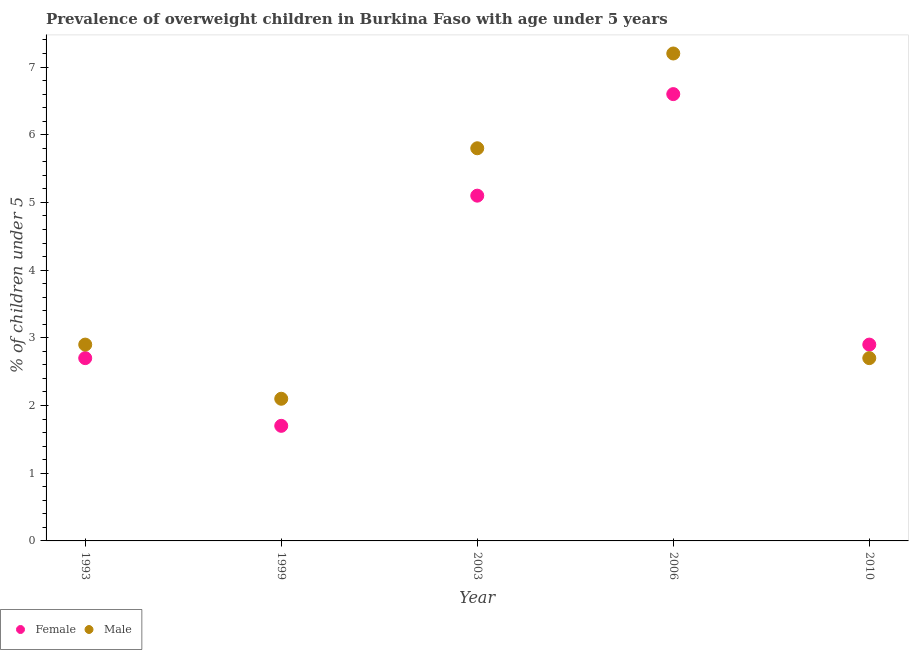What is the percentage of obese male children in 2003?
Ensure brevity in your answer.  5.8. Across all years, what is the maximum percentage of obese male children?
Provide a short and direct response. 7.2. Across all years, what is the minimum percentage of obese male children?
Your response must be concise. 2.1. In which year was the percentage of obese female children maximum?
Provide a short and direct response. 2006. In which year was the percentage of obese female children minimum?
Give a very brief answer. 1999. What is the total percentage of obese female children in the graph?
Provide a short and direct response. 19. What is the difference between the percentage of obese female children in 1999 and that in 2010?
Keep it short and to the point. -1.2. What is the difference between the percentage of obese male children in 2003 and the percentage of obese female children in 2010?
Provide a succinct answer. 2.9. What is the average percentage of obese male children per year?
Offer a very short reply. 4.14. In the year 2010, what is the difference between the percentage of obese male children and percentage of obese female children?
Provide a short and direct response. -0.2. In how many years, is the percentage of obese male children greater than 1 %?
Your response must be concise. 5. What is the ratio of the percentage of obese female children in 1999 to that in 2003?
Make the answer very short. 0.33. Is the difference between the percentage of obese female children in 2006 and 2010 greater than the difference between the percentage of obese male children in 2006 and 2010?
Offer a terse response. No. What is the difference between the highest and the second highest percentage of obese female children?
Offer a terse response. 1.5. What is the difference between the highest and the lowest percentage of obese female children?
Offer a terse response. 4.9. In how many years, is the percentage of obese female children greater than the average percentage of obese female children taken over all years?
Offer a terse response. 2. Is the sum of the percentage of obese male children in 1999 and 2003 greater than the maximum percentage of obese female children across all years?
Keep it short and to the point. Yes. Is the percentage of obese female children strictly greater than the percentage of obese male children over the years?
Offer a very short reply. No. Is the percentage of obese male children strictly less than the percentage of obese female children over the years?
Make the answer very short. No. How many years are there in the graph?
Your answer should be compact. 5. What is the difference between two consecutive major ticks on the Y-axis?
Make the answer very short. 1. Are the values on the major ticks of Y-axis written in scientific E-notation?
Offer a very short reply. No. Does the graph contain grids?
Your answer should be compact. No. Where does the legend appear in the graph?
Your response must be concise. Bottom left. How many legend labels are there?
Offer a terse response. 2. How are the legend labels stacked?
Provide a succinct answer. Horizontal. What is the title of the graph?
Give a very brief answer. Prevalence of overweight children in Burkina Faso with age under 5 years. Does "By country of origin" appear as one of the legend labels in the graph?
Offer a terse response. No. What is the label or title of the Y-axis?
Your answer should be very brief.  % of children under 5. What is the  % of children under 5 in Female in 1993?
Give a very brief answer. 2.7. What is the  % of children under 5 of Male in 1993?
Offer a terse response. 2.9. What is the  % of children under 5 in Female in 1999?
Your answer should be compact. 1.7. What is the  % of children under 5 of Male in 1999?
Give a very brief answer. 2.1. What is the  % of children under 5 of Female in 2003?
Your response must be concise. 5.1. What is the  % of children under 5 of Male in 2003?
Provide a succinct answer. 5.8. What is the  % of children under 5 in Female in 2006?
Your answer should be compact. 6.6. What is the  % of children under 5 in Male in 2006?
Offer a very short reply. 7.2. What is the  % of children under 5 in Female in 2010?
Make the answer very short. 2.9. What is the  % of children under 5 in Male in 2010?
Offer a very short reply. 2.7. Across all years, what is the maximum  % of children under 5 of Female?
Your answer should be compact. 6.6. Across all years, what is the maximum  % of children under 5 in Male?
Your answer should be very brief. 7.2. Across all years, what is the minimum  % of children under 5 of Female?
Provide a short and direct response. 1.7. Across all years, what is the minimum  % of children under 5 of Male?
Offer a very short reply. 2.1. What is the total  % of children under 5 in Male in the graph?
Offer a very short reply. 20.7. What is the difference between the  % of children under 5 in Male in 1993 and that in 2003?
Give a very brief answer. -2.9. What is the difference between the  % of children under 5 in Female in 1993 and that in 2006?
Make the answer very short. -3.9. What is the difference between the  % of children under 5 in Female in 1993 and that in 2010?
Your response must be concise. -0.2. What is the difference between the  % of children under 5 in Male in 1999 and that in 2006?
Provide a short and direct response. -5.1. What is the difference between the  % of children under 5 in Female in 1999 and that in 2010?
Offer a very short reply. -1.2. What is the difference between the  % of children under 5 in Female in 2003 and that in 2006?
Offer a terse response. -1.5. What is the difference between the  % of children under 5 in Female in 2003 and that in 2010?
Your answer should be compact. 2.2. What is the difference between the  % of children under 5 in Male in 2003 and that in 2010?
Offer a very short reply. 3.1. What is the difference between the  % of children under 5 in Female in 1993 and the  % of children under 5 in Male in 2003?
Your response must be concise. -3.1. What is the difference between the  % of children under 5 in Female in 1993 and the  % of children under 5 in Male in 2006?
Offer a terse response. -4.5. What is the difference between the  % of children under 5 in Female in 1999 and the  % of children under 5 in Male in 2006?
Offer a very short reply. -5.5. What is the difference between the  % of children under 5 in Female in 2003 and the  % of children under 5 in Male in 2006?
Give a very brief answer. -2.1. What is the difference between the  % of children under 5 of Female in 2003 and the  % of children under 5 of Male in 2010?
Your answer should be compact. 2.4. What is the average  % of children under 5 in Male per year?
Make the answer very short. 4.14. In the year 1993, what is the difference between the  % of children under 5 in Female and  % of children under 5 in Male?
Your response must be concise. -0.2. In the year 2003, what is the difference between the  % of children under 5 of Female and  % of children under 5 of Male?
Offer a very short reply. -0.7. In the year 2006, what is the difference between the  % of children under 5 in Female and  % of children under 5 in Male?
Keep it short and to the point. -0.6. In the year 2010, what is the difference between the  % of children under 5 of Female and  % of children under 5 of Male?
Your answer should be very brief. 0.2. What is the ratio of the  % of children under 5 of Female in 1993 to that in 1999?
Your response must be concise. 1.59. What is the ratio of the  % of children under 5 in Male in 1993 to that in 1999?
Give a very brief answer. 1.38. What is the ratio of the  % of children under 5 of Female in 1993 to that in 2003?
Ensure brevity in your answer.  0.53. What is the ratio of the  % of children under 5 of Female in 1993 to that in 2006?
Provide a succinct answer. 0.41. What is the ratio of the  % of children under 5 in Male in 1993 to that in 2006?
Offer a terse response. 0.4. What is the ratio of the  % of children under 5 of Male in 1993 to that in 2010?
Offer a very short reply. 1.07. What is the ratio of the  % of children under 5 in Female in 1999 to that in 2003?
Offer a terse response. 0.33. What is the ratio of the  % of children under 5 in Male in 1999 to that in 2003?
Provide a short and direct response. 0.36. What is the ratio of the  % of children under 5 of Female in 1999 to that in 2006?
Provide a short and direct response. 0.26. What is the ratio of the  % of children under 5 of Male in 1999 to that in 2006?
Your answer should be very brief. 0.29. What is the ratio of the  % of children under 5 in Female in 1999 to that in 2010?
Offer a very short reply. 0.59. What is the ratio of the  % of children under 5 in Female in 2003 to that in 2006?
Offer a very short reply. 0.77. What is the ratio of the  % of children under 5 of Male in 2003 to that in 2006?
Provide a short and direct response. 0.81. What is the ratio of the  % of children under 5 in Female in 2003 to that in 2010?
Provide a short and direct response. 1.76. What is the ratio of the  % of children under 5 of Male in 2003 to that in 2010?
Provide a short and direct response. 2.15. What is the ratio of the  % of children under 5 in Female in 2006 to that in 2010?
Your answer should be compact. 2.28. What is the ratio of the  % of children under 5 in Male in 2006 to that in 2010?
Ensure brevity in your answer.  2.67. What is the difference between the highest and the second highest  % of children under 5 in Male?
Offer a terse response. 1.4. 